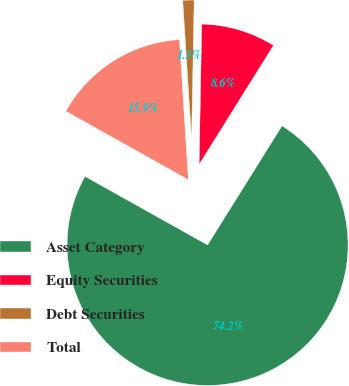<chart> <loc_0><loc_0><loc_500><loc_500><pie_chart><fcel>Asset Category<fcel>Equity Securities<fcel>Debt Securities<fcel>Total<nl><fcel>74.23%<fcel>8.59%<fcel>1.3%<fcel>15.88%<nl></chart> 